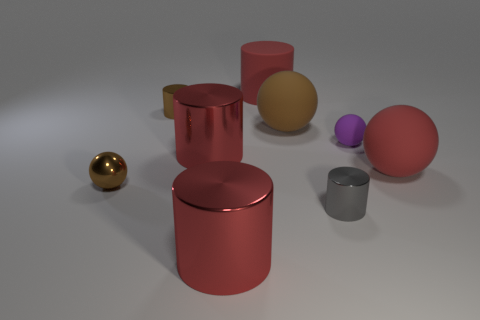Do the purple ball and the big red thing that is on the right side of the big red matte cylinder have the same material?
Your answer should be compact. Yes. There is a rubber sphere that is the same color as the matte cylinder; what is its size?
Offer a very short reply. Large. Are there any tiny brown objects made of the same material as the purple thing?
Ensure brevity in your answer.  No. What number of objects are either brown spheres that are right of the small brown metallic cylinder or purple balls that are behind the small gray metal cylinder?
Give a very brief answer. 2. There is a purple thing; does it have the same shape as the large red thing that is to the right of the tiny gray cylinder?
Your answer should be very brief. Yes. How many other things are there of the same shape as the large brown thing?
Provide a succinct answer. 3. How many things are either tiny brown shiny objects or brown cylinders?
Provide a succinct answer. 2. Is the big rubber cylinder the same color as the metallic ball?
Provide a short and direct response. No. Is there any other thing that is the same size as the red sphere?
Ensure brevity in your answer.  Yes. What shape is the brown thing to the right of the metal object in front of the small gray metallic cylinder?
Offer a terse response. Sphere. 